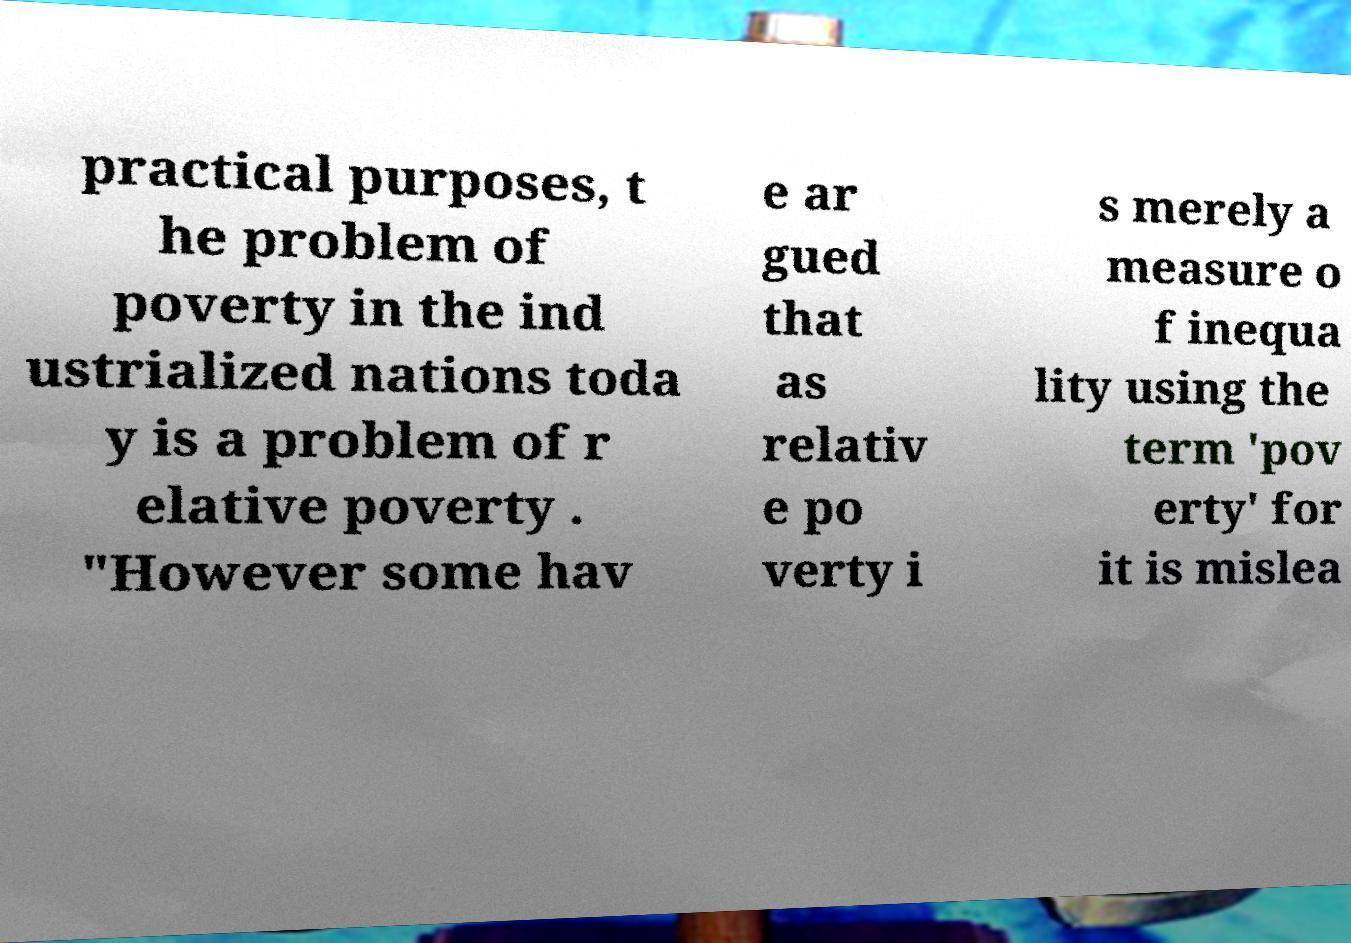Please identify and transcribe the text found in this image. practical purposes, t he problem of poverty in the ind ustrialized nations toda y is a problem of r elative poverty . "However some hav e ar gued that as relativ e po verty i s merely a measure o f inequa lity using the term 'pov erty' for it is mislea 